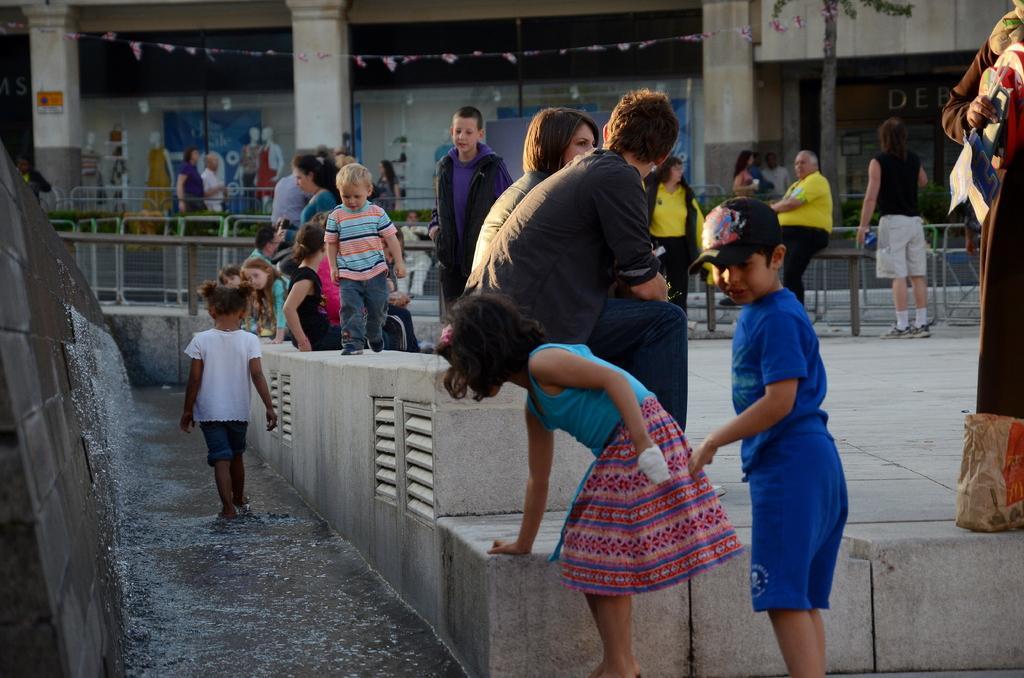Could you give a brief overview of what you see in this image? As we can see in the image there are few people here and there, fence, chairs and a building. 